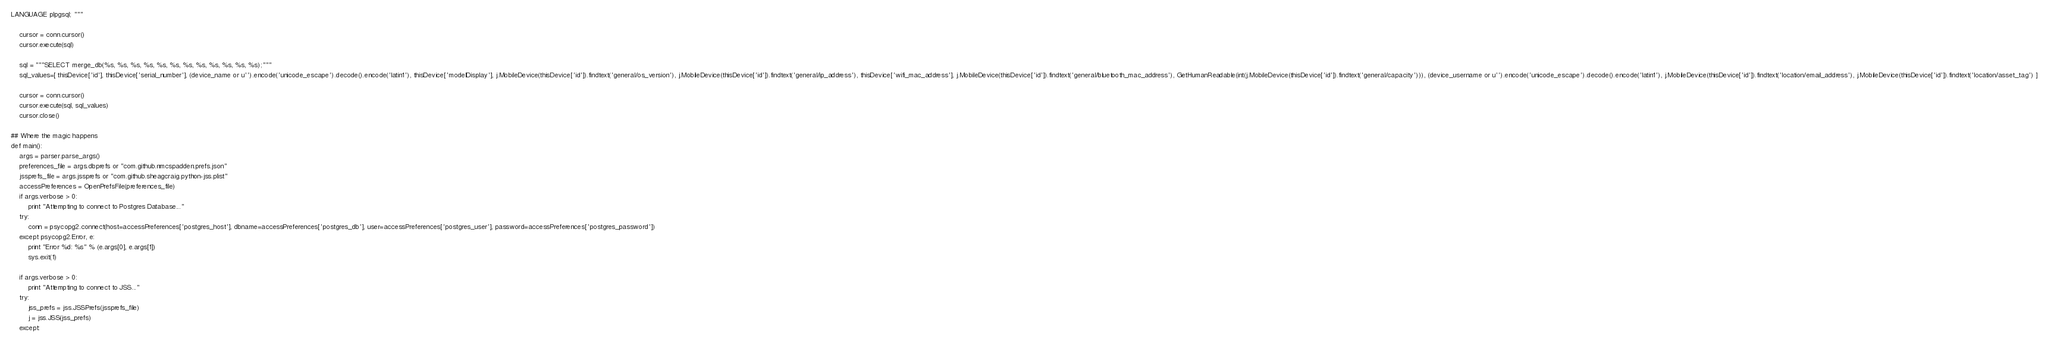<code> <loc_0><loc_0><loc_500><loc_500><_Python_>LANGUAGE plpgsql; """
	
	cursor = conn.cursor()
	cursor.execute(sql)
	
	sql = """SELECT merge_db(%s, %s, %s, %s, %s, %s, %s, %s, %s, %s, %s, %s);"""
	sql_values=[ thisDevice['id'], thisDevice['serial_number'], (device_name or u'').encode('unicode_escape').decode().encode('latin1'), thisDevice['modelDisplay'], j.MobileDevice(thisDevice['id']).findtext('general/os_version'), j.MobileDevice(thisDevice['id']).findtext('general/ip_address'), thisDevice['wifi_mac_address'], j.MobileDevice(thisDevice['id']).findtext('general/bluetooth_mac_address'), GetHumanReadable(int(j.MobileDevice(thisDevice['id']).findtext('general/capacity'))), (device_username or u'').encode('unicode_escape').decode().encode('latin1'), j.MobileDevice(thisDevice['id']).findtext('location/email_address'), j.MobileDevice(thisDevice['id']).findtext('location/asset_tag') ]
	
	cursor = conn.cursor()
	cursor.execute(sql, sql_values)
	cursor.close()

## Where the magic happens
def main():
	args = parser.parse_args()
	preferences_file = args.dbprefs or "com.github.nmcspadden.prefs.json"
	jssprefs_file = args.jssprefs or "com.github.sheagcraig.python-jss.plist"
	accessPreferences = OpenPrefsFile(preferences_file)
	if args.verbose > 0:
		print "Attempting to connect to Postgres Database..."
	try:
		conn = psycopg2.connect(host=accessPreferences['postgres_host'], dbname=accessPreferences['postgres_db'], user=accessPreferences['postgres_user'], password=accessPreferences['postgres_password'])
	except psycopg2.Error, e:
		print "Error %d: %s" % (e.args[0], e.args[1])
		sys.exit(1)

	if args.verbose > 0:
		print "Attempting to connect to JSS..."	
	try:
		jss_prefs = jss.JSSPrefs(jssprefs_file)
		j = jss.JSS(jss_prefs)
	except:</code> 